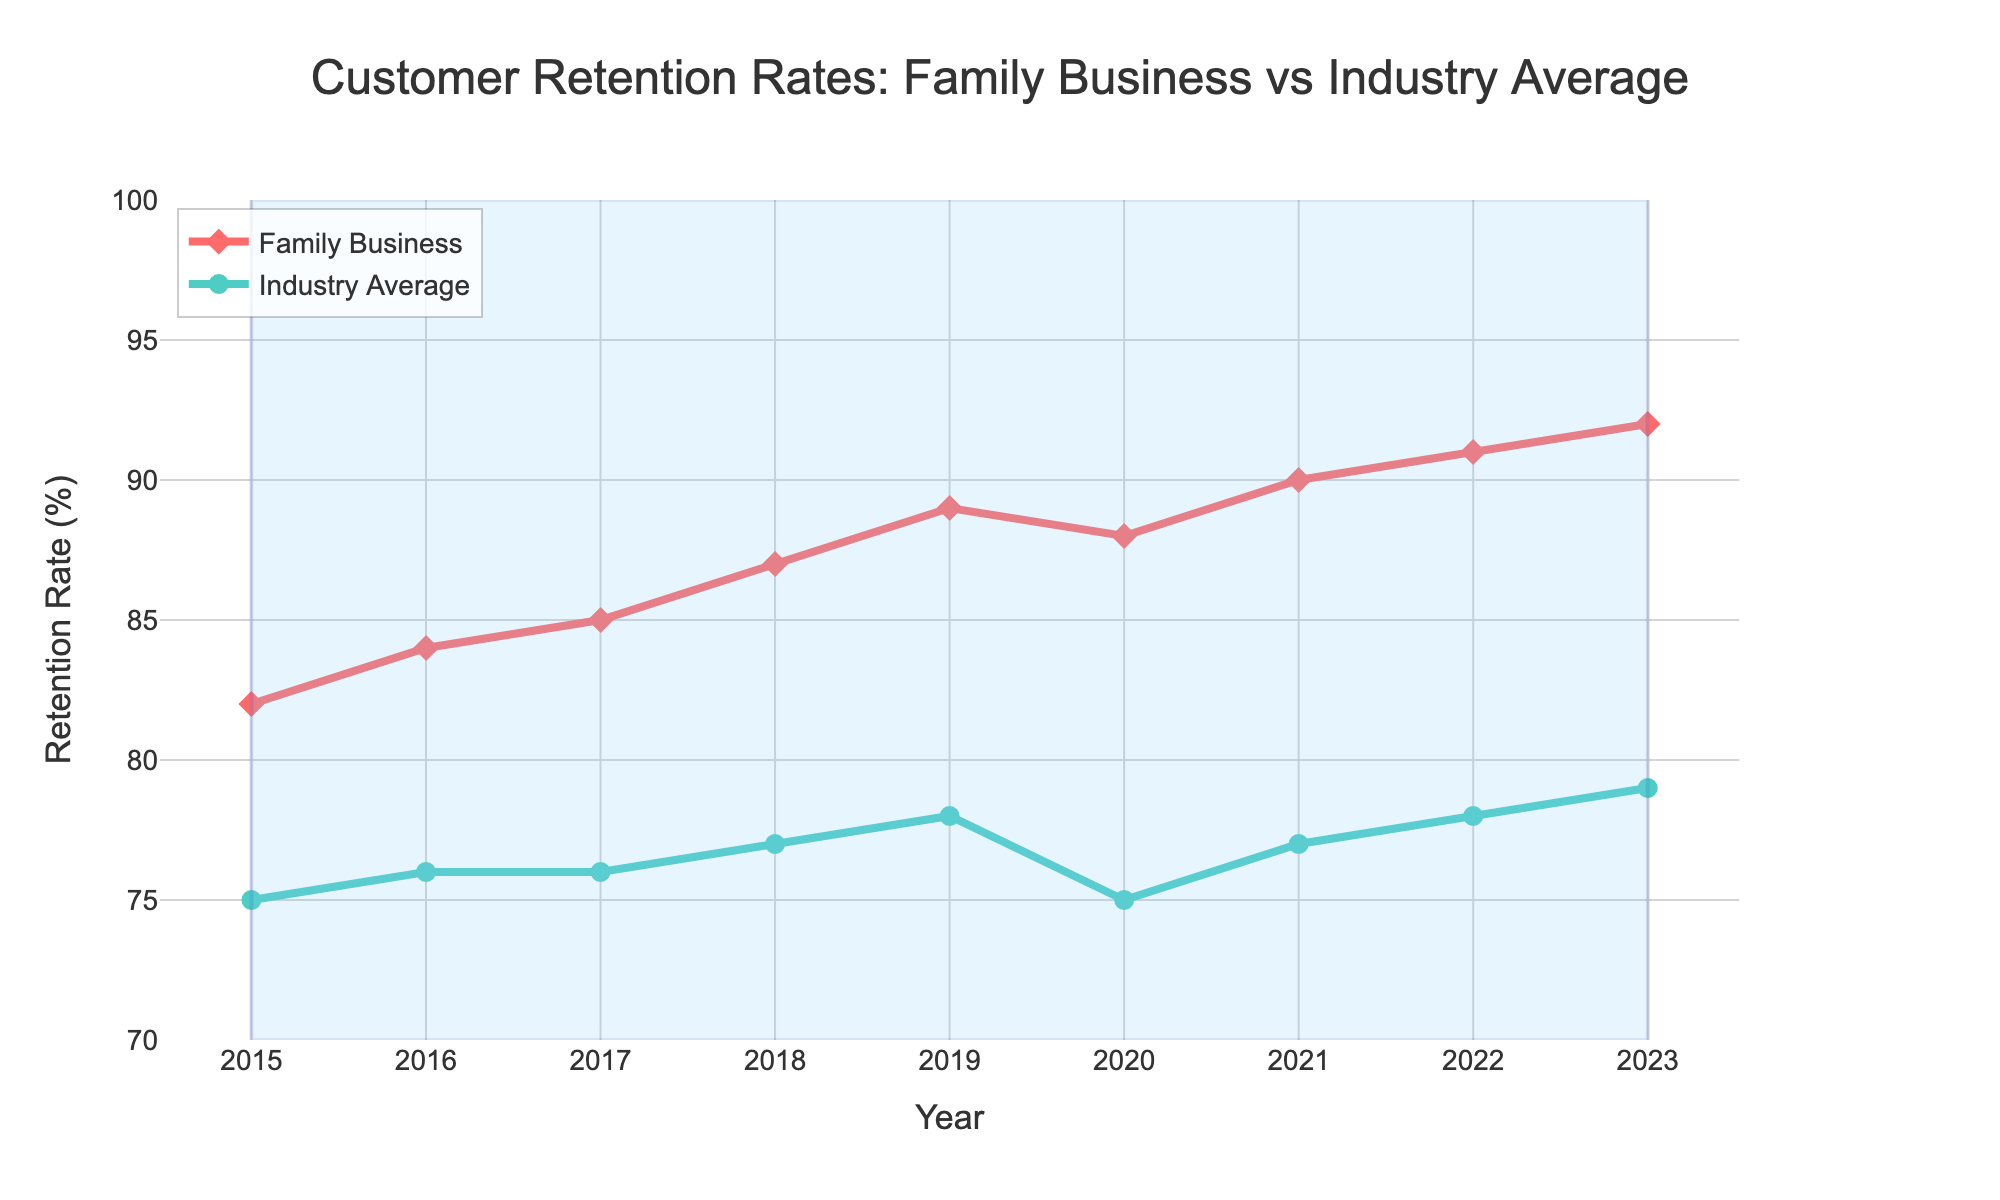What is the customer retention rate of the family business in 2021? Look at the data point for the year 2021 under the "Family Business Retention Rate" line. The data point indicates a retention rate of 90.
Answer: 90% How did the retention rate for the family business change from 2020 to 2021? Compare the retention rates for the family business in 2020 and 2021. The rate increases from 88% in 2020 to 90% in 2021, an increase of 2%.
Answer: Increase of 2% Is there any year where the family business retention rate decreased compared to the previous year? Check the trend lines for the family business and identify any year where the retention rate decreases. The only year where there is a decrease is from 2019 (89%) to 2020 (88%).
Answer: Yes, from 2019 to 2020 Which year saw the highest customer retention rate for the family business? Locate the peak point on the "Family Business Retention Rate" line. The highest retention rate observed is 92% in the year 2023.
Answer: 2023 In which year was the gap between the family business retention rate and industry average retention rate the largest? Calculate the differences between the family business retention rate and the industry average for each year. The largest gap occurs in 2020, where the family business rate is 88% and the industry average is 75%, a difference of 13%.
Answer: 2020 What is the average customer retention rate for the family business over the given period? Sum up the retention rates from 2015 to 2023 and divide by the number of years (9 years). (82 + 84 + 85 + 87 + 89 + 88 + 90 + 91 + 92) / 9 = 87.6.
Answer: 87.6 How does the family business retention rate in 2023 compare to the industry average in the same year? Check the data points for 2023. The family business retention rate is 92% and the industry average is 79%. The family business retention rate is 13% higher than the industry average.
Answer: 13% higher Between which years did the industry average retention rate remain constant? Inspect the "Industry Average Retention Rate" line. The rate remains constant between 2016 and 2017 at 76%.
Answer: Between 2016 and 2017 What is the difference in retention rates between the family business and the industry average in 2018? Locate the data points for 2018. The family business retention rate is 87% while the industry average is 77%. The difference is 87 - 77 = 10%.
Answer: 10% What color represents the family business retention rate on the chart? Look at the color of the line marked as "Family Business." This line is red.
Answer: Red 